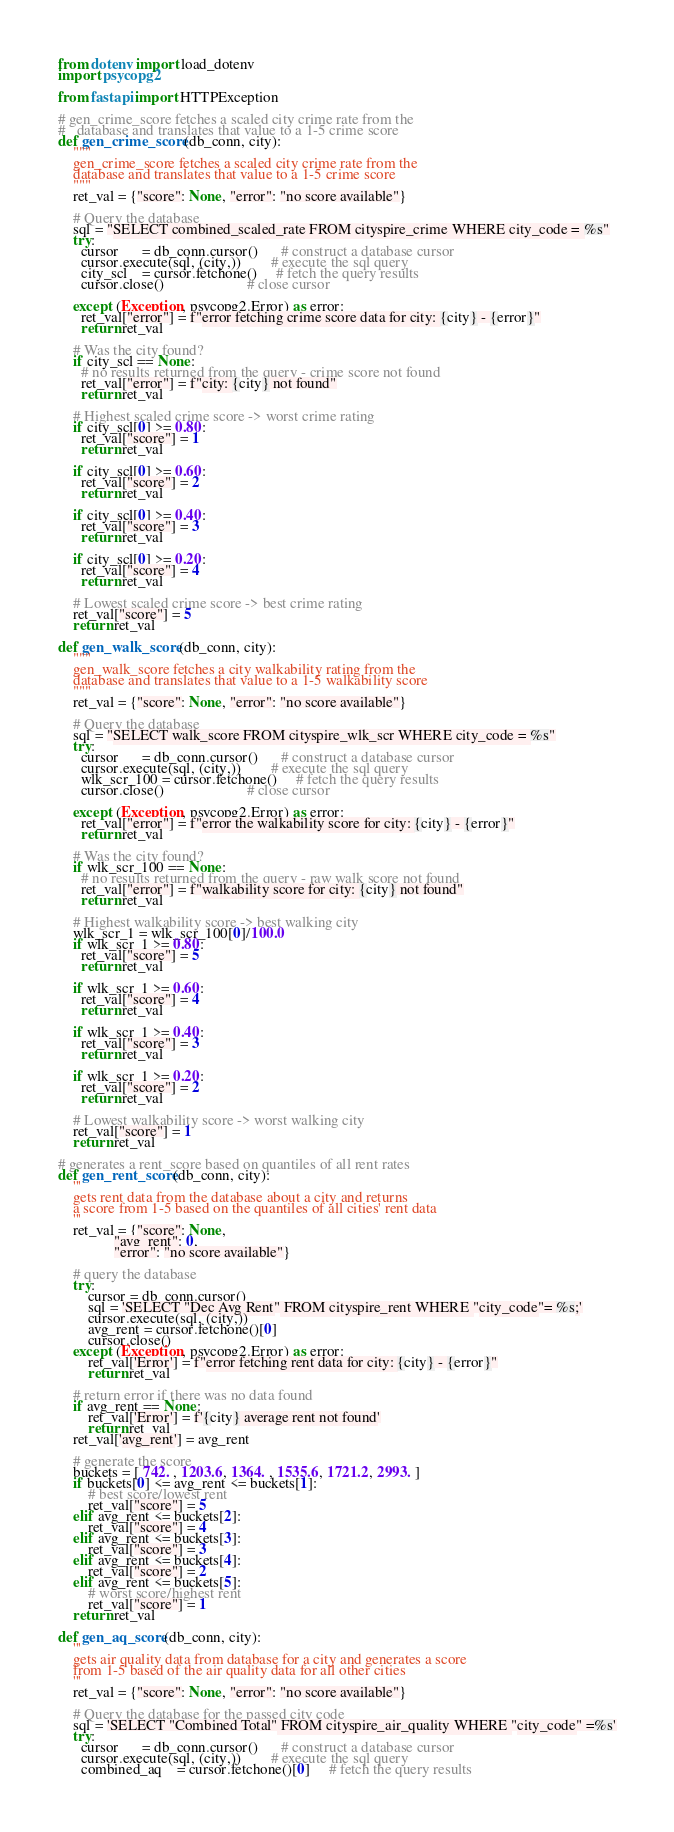<code> <loc_0><loc_0><loc_500><loc_500><_Python_>from dotenv import load_dotenv
import psycopg2

from fastapi import HTTPException

# gen_crime_score fetches a scaled city crime rate from the
#   database and translates that value to a 1-5 crime score
def gen_crime_score(db_conn, city):
    """
    gen_crime_score fetches a scaled city crime rate from the
    database and translates that value to a 1-5 crime score
    """
    ret_val = {"score": None, "error": "no score available"}

    # Query the database
    sql = "SELECT combined_scaled_rate FROM cityspire_crime WHERE city_code = %s"
    try:
      cursor      = db_conn.cursor()      # construct a database cursor
      cursor.execute(sql, (city,))        # execute the sql query
      city_scl    = cursor.fetchone()     # fetch the query results
      cursor.close()                      # close cursor

    except (Exception, psycopg2.Error) as error:
      ret_val["error"] = f"error fetching crime score data for city: {city} - {error}"
      return ret_val

    # Was the city found?
    if city_scl == None:
      # no results returned from the query - crime score not found
      ret_val["error"] = f"city: {city} not found"
      return ret_val

    # Highest scaled crime score -> worst crime rating
    if city_scl[0] >= 0.80:
      ret_val["score"] = 1
      return ret_val
    
    if city_scl[0] >= 0.60:
      ret_val["score"] = 2
      return ret_val

    if city_scl[0] >= 0.40:
      ret_val["score"] = 3
      return ret_val

    if city_scl[0] >= 0.20:
      ret_val["score"] = 4
      return ret_val

    # Lowest scaled crime score -> best crime rating
    ret_val["score"] = 5
    return ret_val

def gen_walk_score(db_conn, city):
    """
    gen_walk_score fetches a city walkability rating from the
    database and translates that value to a 1-5 walkability score
    """
    ret_val = {"score": None, "error": "no score available"}

    # Query the database
    sql = "SELECT walk_score FROM cityspire_wlk_scr WHERE city_code = %s"
    try:
      cursor      = db_conn.cursor()      # construct a database cursor
      cursor.execute(sql, (city,))        # execute the sql query
      wlk_scr_100 = cursor.fetchone()     # fetch the query results
      cursor.close()                      # close cursor

    except (Exception, psycopg2.Error) as error:
      ret_val["error"] = f"error the walkability score for city: {city} - {error}"
      return ret_val

    # Was the city found?
    if wlk_scr_100 == None:
      # no results returned from the query - raw walk score not found
      ret_val["error"] = f"walkability score for city: {city} not found"
      return ret_val

    # Highest walkability score -> best walking city
    wlk_scr_1 = wlk_scr_100[0]/100.0
    if wlk_scr_1 >= 0.80:
      ret_val["score"] = 5
      return ret_val
    
    if wlk_scr_1 >= 0.60:
      ret_val["score"] = 4
      return ret_val

    if wlk_scr_1 >= 0.40:
      ret_val["score"] = 3
      return ret_val

    if wlk_scr_1 >= 0.20:
      ret_val["score"] = 2
      return ret_val

    # Lowest walkability score -> worst walking city
    ret_val["score"] = 1
    return ret_val

# generates a rent_score based on quantiles of all rent rates
def gen_rent_score(db_conn, city):
    '''
    gets rent data from the database about a city and returns 
    a score from 1-5 based on the quantiles of all cities' rent data
    '''
    ret_val = {"score": None,
               "avg_rent": 0,
               "error": "no score available"}
    
    # query the database
    try:
        cursor = db_conn.cursor()
        sql = 'SELECT "Dec Avg Rent" FROM cityspire_rent WHERE "city_code"= %s;'
        cursor.execute(sql, (city,))
        avg_rent = cursor.fetchone()[0]
        cursor.close()
    except (Exception, psycopg2.Error) as error:
        ret_val['Error'] = f"error fetching rent data for city: {city} - {error}"
        return ret_val

    # return error if there was no data found
    if avg_rent == None:
        ret_val['Error'] = f'{city} average rent not found'
        return ret_val
    ret_val['avg_rent'] = avg_rent    
    
    # generate the score
    buckets = [ 742. , 1203.6, 1364. , 1535.6, 1721.2, 2993. ]
    if buckets[0] <= avg_rent <= buckets[1]:
        # best score/lowest rent
        ret_val["score"] = 5
    elif avg_rent <= buckets[2]:
        ret_val["score"] = 4
    elif avg_rent <= buckets[3]:
        ret_val["score"] = 3
    elif avg_rent <= buckets[4]:
        ret_val["score"] = 2
    elif avg_rent <= buckets[5]:
        # worst score/highest rent
        ret_val["score"] = 1
    return ret_val    

def gen_aq_score(db_conn, city):
    '''
    gets air quality data from database for a city and generates a score
    from 1-5 based of the air quality data for all other cities
    '''
    ret_val = {"score": None, "error": "no score available"}
    
    # Query the database for the passed city code
    sql = 'SELECT "Combined Total" FROM cityspire_air_quality WHERE "city_code" =%s'
    try:
      cursor      = db_conn.cursor()      # construct a database cursor
      cursor.execute(sql, (city,))        # execute the sql query
      combined_aq    = cursor.fetchone()[0]     # fetch the query results</code> 